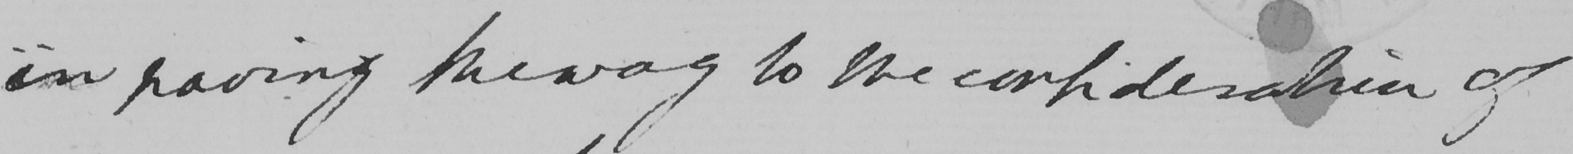Transcribe the text shown in this historical manuscript line. in paving the way to the consideration of 